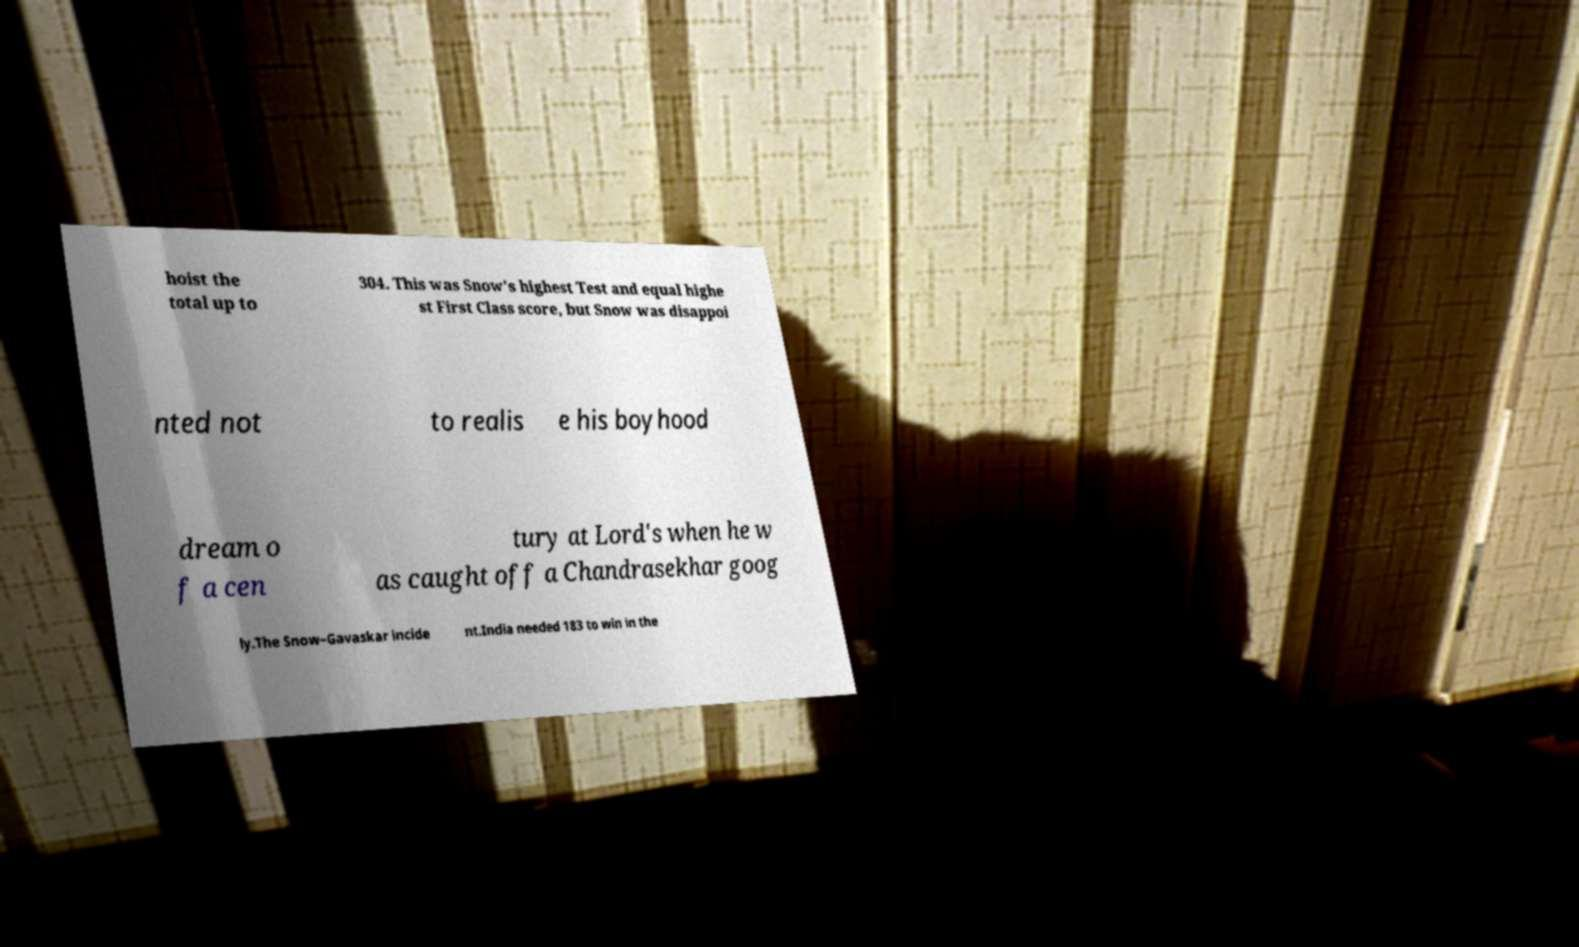Please identify and transcribe the text found in this image. hoist the total up to 304. This was Snow's highest Test and equal highe st First Class score, but Snow was disappoi nted not to realis e his boyhood dream o f a cen tury at Lord's when he w as caught off a Chandrasekhar goog ly.The Snow–Gavaskar incide nt.India needed 183 to win in the 